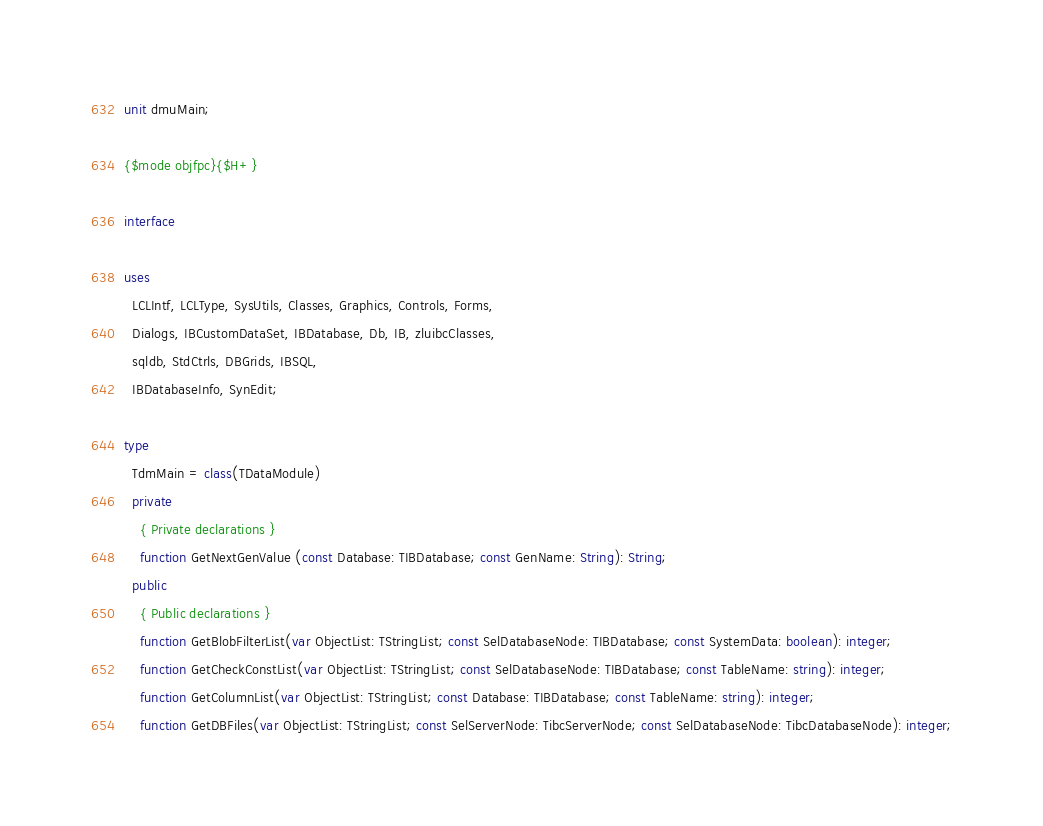Convert code to text. <code><loc_0><loc_0><loc_500><loc_500><_Pascal_>unit dmuMain;

{$mode objfpc}{$H+}

interface

uses
  LCLIntf, LCLType, SysUtils, Classes, Graphics, Controls, Forms,
  Dialogs, IBCustomDataSet, IBDatabase, Db, IB, zluibcClasses,
  sqldb, StdCtrls, DBGrids, IBSQL,
  IBDatabaseInfo, SynEdit;

type
  TdmMain = class(TDataModule)
  private
    { Private declarations }
    function GetNextGenValue (const Database: TIBDatabase; const GenName: String): String;
  public
    { Public declarations }
    function GetBlobFilterList(var ObjectList: TStringList; const SelDatabaseNode: TIBDatabase; const SystemData: boolean): integer;
    function GetCheckConstList(var ObjectList: TStringList; const SelDatabaseNode: TIBDatabase; const TableName: string): integer;
    function GetColumnList(var ObjectList: TStringList; const Database: TIBDatabase; const TableName: string): integer;
    function GetDBFiles(var ObjectList: TStringList; const SelServerNode: TibcServerNode; const SelDatabaseNode: TibcDatabaseNode): integer;</code> 